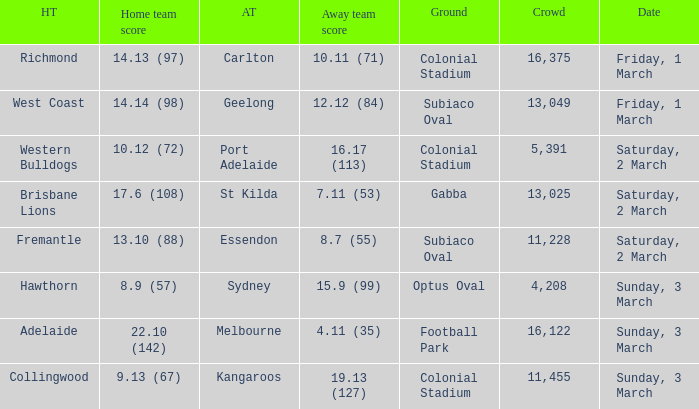Who is the opponent when the home team achieved 1 St Kilda. 